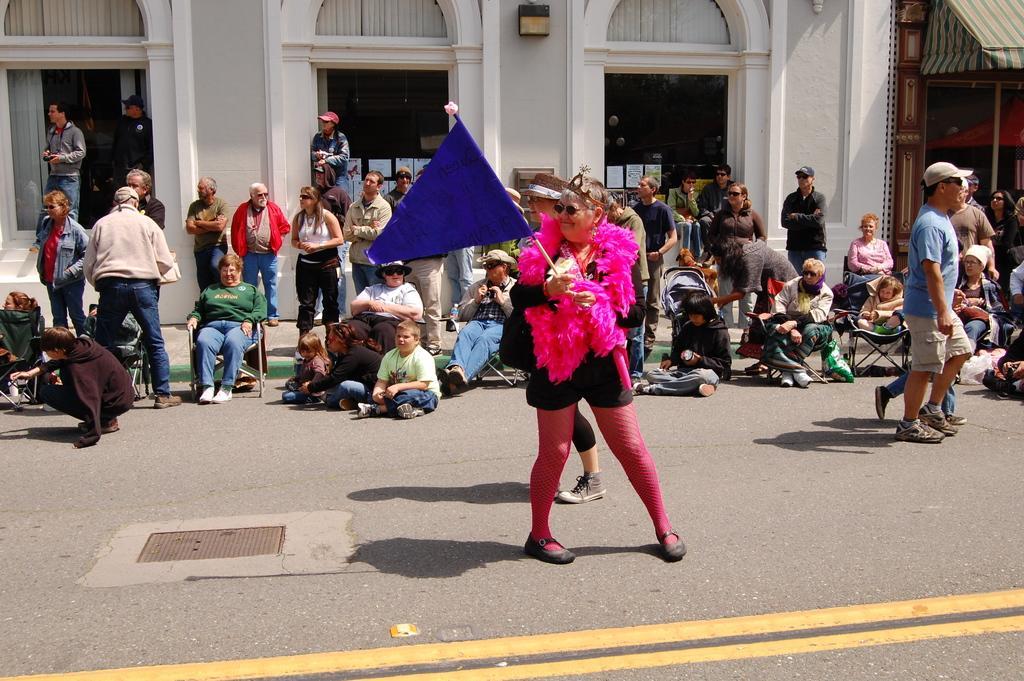In one or two sentences, can you explain what this image depicts? In the center of the image there is a person standing on the road holding a flag. In the background we can see building, door, window and many persons on the road. 